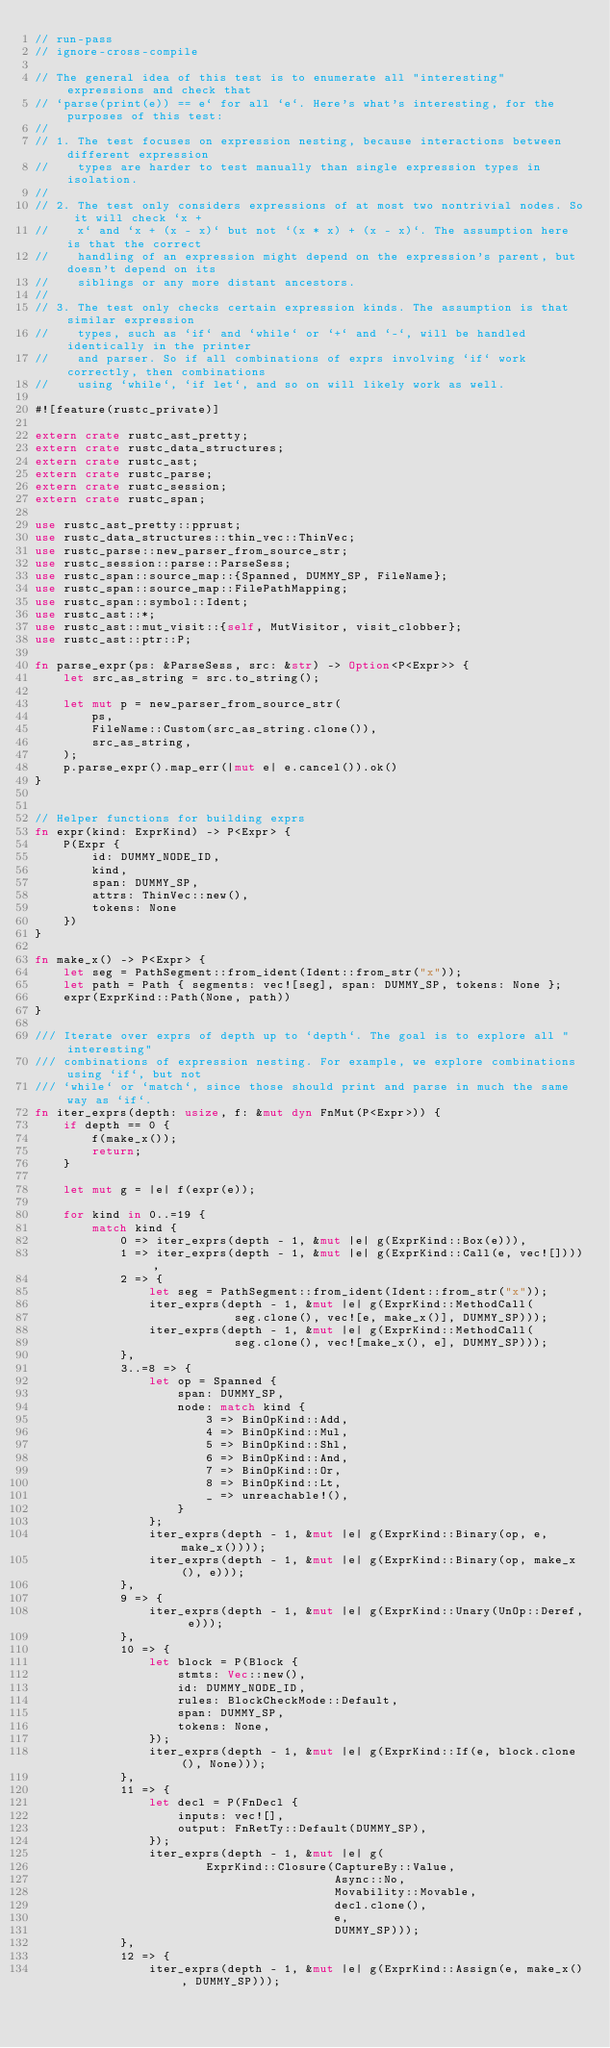<code> <loc_0><loc_0><loc_500><loc_500><_Rust_>// run-pass
// ignore-cross-compile

// The general idea of this test is to enumerate all "interesting" expressions and check that
// `parse(print(e)) == e` for all `e`. Here's what's interesting, for the purposes of this test:
//
// 1. The test focuses on expression nesting, because interactions between different expression
//    types are harder to test manually than single expression types in isolation.
//
// 2. The test only considers expressions of at most two nontrivial nodes. So it will check `x +
//    x` and `x + (x - x)` but not `(x * x) + (x - x)`. The assumption here is that the correct
//    handling of an expression might depend on the expression's parent, but doesn't depend on its
//    siblings or any more distant ancestors.
//
// 3. The test only checks certain expression kinds. The assumption is that similar expression
//    types, such as `if` and `while` or `+` and `-`, will be handled identically in the printer
//    and parser. So if all combinations of exprs involving `if` work correctly, then combinations
//    using `while`, `if let`, and so on will likely work as well.

#![feature(rustc_private)]

extern crate rustc_ast_pretty;
extern crate rustc_data_structures;
extern crate rustc_ast;
extern crate rustc_parse;
extern crate rustc_session;
extern crate rustc_span;

use rustc_ast_pretty::pprust;
use rustc_data_structures::thin_vec::ThinVec;
use rustc_parse::new_parser_from_source_str;
use rustc_session::parse::ParseSess;
use rustc_span::source_map::{Spanned, DUMMY_SP, FileName};
use rustc_span::source_map::FilePathMapping;
use rustc_span::symbol::Ident;
use rustc_ast::*;
use rustc_ast::mut_visit::{self, MutVisitor, visit_clobber};
use rustc_ast::ptr::P;

fn parse_expr(ps: &ParseSess, src: &str) -> Option<P<Expr>> {
    let src_as_string = src.to_string();

    let mut p = new_parser_from_source_str(
        ps,
        FileName::Custom(src_as_string.clone()),
        src_as_string,
    );
    p.parse_expr().map_err(|mut e| e.cancel()).ok()
}


// Helper functions for building exprs
fn expr(kind: ExprKind) -> P<Expr> {
    P(Expr {
        id: DUMMY_NODE_ID,
        kind,
        span: DUMMY_SP,
        attrs: ThinVec::new(),
        tokens: None
    })
}

fn make_x() -> P<Expr> {
    let seg = PathSegment::from_ident(Ident::from_str("x"));
    let path = Path { segments: vec![seg], span: DUMMY_SP, tokens: None };
    expr(ExprKind::Path(None, path))
}

/// Iterate over exprs of depth up to `depth`. The goal is to explore all "interesting"
/// combinations of expression nesting. For example, we explore combinations using `if`, but not
/// `while` or `match`, since those should print and parse in much the same way as `if`.
fn iter_exprs(depth: usize, f: &mut dyn FnMut(P<Expr>)) {
    if depth == 0 {
        f(make_x());
        return;
    }

    let mut g = |e| f(expr(e));

    for kind in 0..=19 {
        match kind {
            0 => iter_exprs(depth - 1, &mut |e| g(ExprKind::Box(e))),
            1 => iter_exprs(depth - 1, &mut |e| g(ExprKind::Call(e, vec![]))),
            2 => {
                let seg = PathSegment::from_ident(Ident::from_str("x"));
                iter_exprs(depth - 1, &mut |e| g(ExprKind::MethodCall(
                            seg.clone(), vec![e, make_x()], DUMMY_SP)));
                iter_exprs(depth - 1, &mut |e| g(ExprKind::MethodCall(
                            seg.clone(), vec![make_x(), e], DUMMY_SP)));
            },
            3..=8 => {
                let op = Spanned {
                    span: DUMMY_SP,
                    node: match kind {
                        3 => BinOpKind::Add,
                        4 => BinOpKind::Mul,
                        5 => BinOpKind::Shl,
                        6 => BinOpKind::And,
                        7 => BinOpKind::Or,
                        8 => BinOpKind::Lt,
                        _ => unreachable!(),
                    }
                };
                iter_exprs(depth - 1, &mut |e| g(ExprKind::Binary(op, e, make_x())));
                iter_exprs(depth - 1, &mut |e| g(ExprKind::Binary(op, make_x(), e)));
            },
            9 => {
                iter_exprs(depth - 1, &mut |e| g(ExprKind::Unary(UnOp::Deref, e)));
            },
            10 => {
                let block = P(Block {
                    stmts: Vec::new(),
                    id: DUMMY_NODE_ID,
                    rules: BlockCheckMode::Default,
                    span: DUMMY_SP,
                    tokens: None,
                });
                iter_exprs(depth - 1, &mut |e| g(ExprKind::If(e, block.clone(), None)));
            },
            11 => {
                let decl = P(FnDecl {
                    inputs: vec![],
                    output: FnRetTy::Default(DUMMY_SP),
                });
                iter_exprs(depth - 1, &mut |e| g(
                        ExprKind::Closure(CaptureBy::Value,
                                          Async::No,
                                          Movability::Movable,
                                          decl.clone(),
                                          e,
                                          DUMMY_SP)));
            },
            12 => {
                iter_exprs(depth - 1, &mut |e| g(ExprKind::Assign(e, make_x(), DUMMY_SP)));</code> 